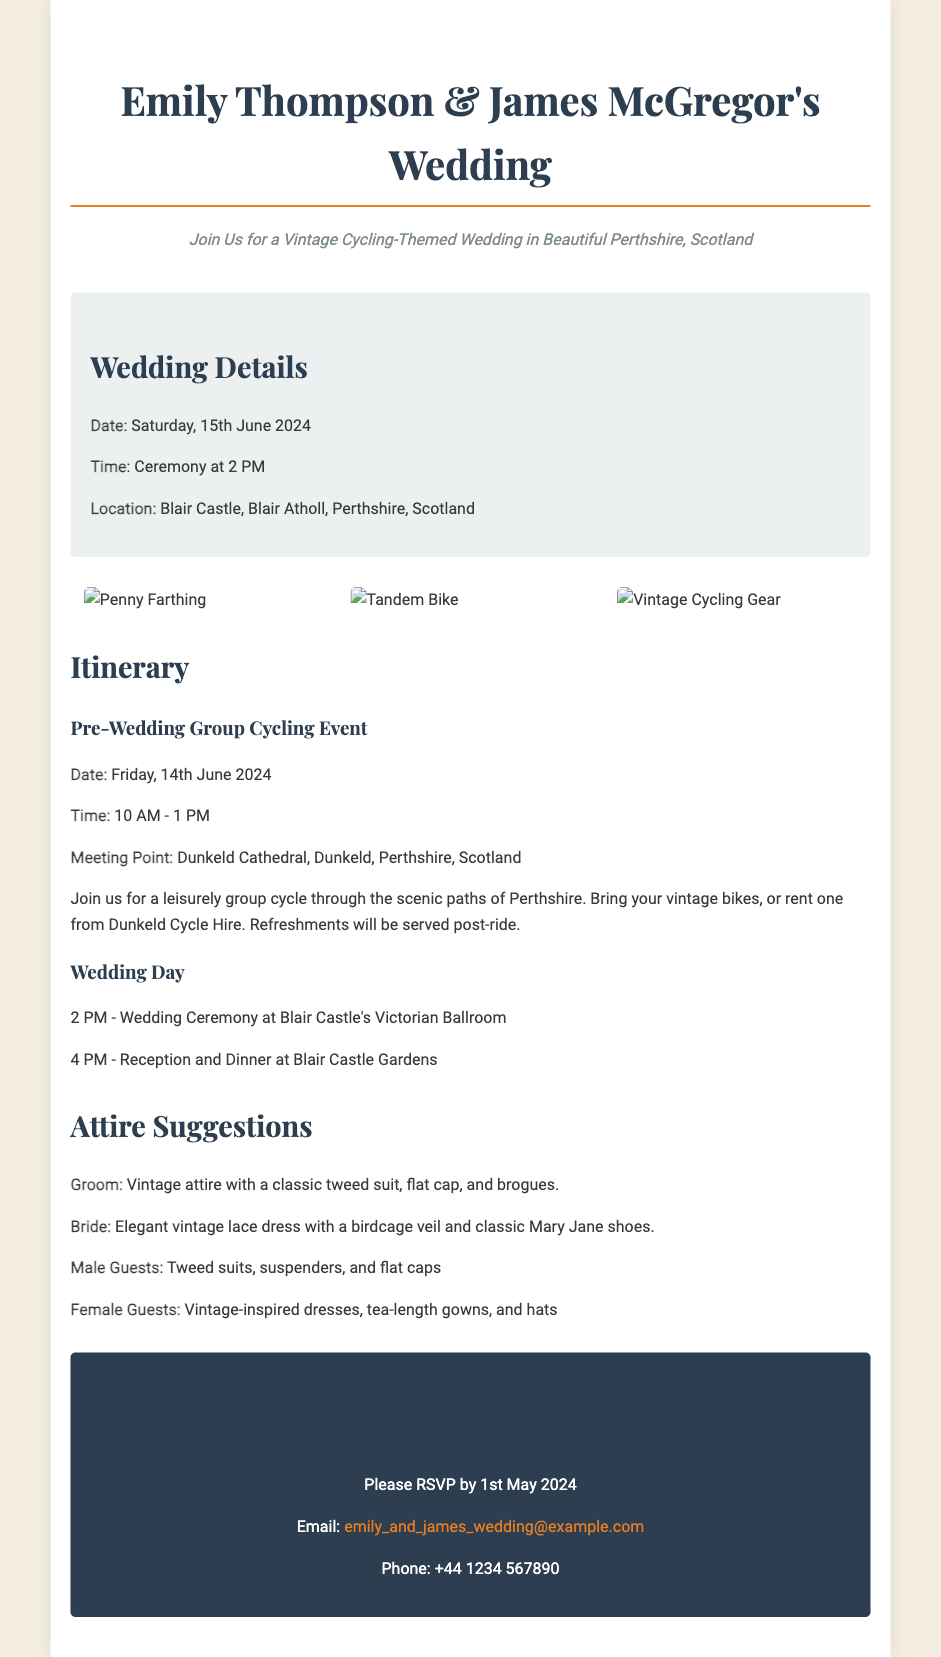What is the date of the wedding? The wedding is scheduled for Saturday, 15th June 2024.
Answer: 15th June 2024 What is the venue for the wedding ceremony? The ceremony will take place at Blair Castle, Blair Atholl, Perthshire, Scotland.
Answer: Blair Castle What time does the pre-wedding group cycling event start? The group cycling event will start at 10 AM on Friday, 14th June 2024.
Answer: 10 AM What attire is suggested for the groom? The groom's suggested attire is a vintage tweed suit, flat cap, and brogues.
Answer: Vintage attire How long will the pre-wedding cycling event last? The pre-wedding cycling event is scheduled to last for 3 hours, from 10 AM to 1 PM.
Answer: 3 hours How should female guests dress for the wedding? Female guests are encouraged to wear vintage-inspired dresses, tea-length gowns, and hats.
Answer: Vintage-inspired dresses What will be the time for the wedding ceremony? The wedding ceremony is set to take place at 2 PM.
Answer: 2 PM When is the RSVP deadline? Guests are asked to RSVP by 1st May 2024.
Answer: 1st May 2024 